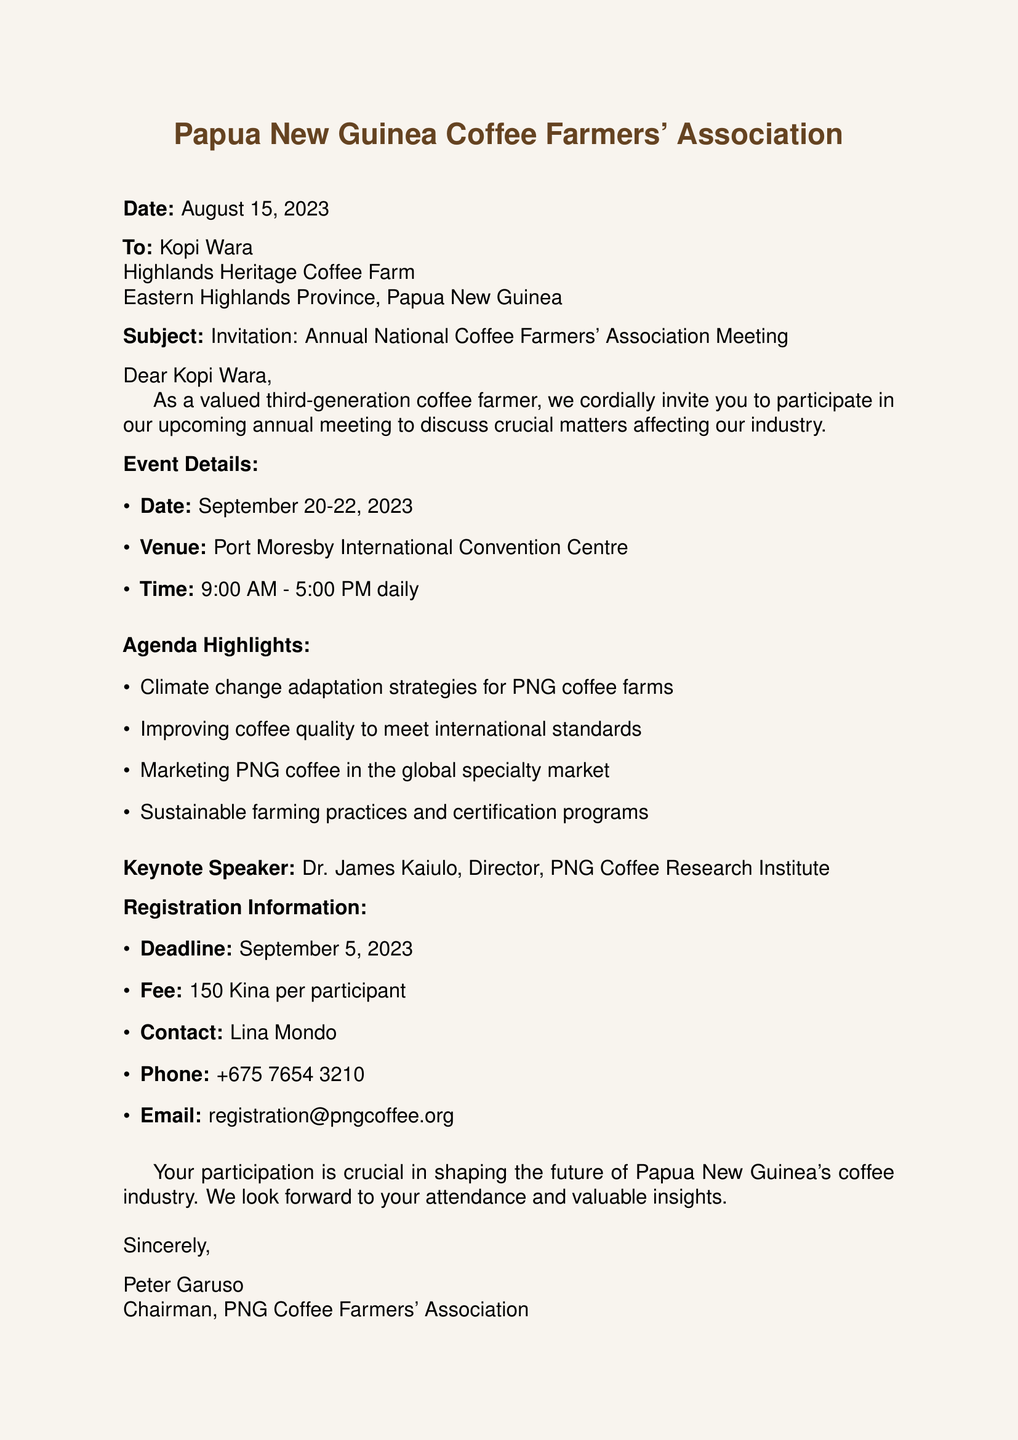What is the date of the meeting? The meeting is scheduled for September 20-22, 2023.
Answer: September 20-22, 2023 What is the venue for the meeting? The venue for the meeting is the Port Moresby International Convention Centre.
Answer: Port Moresby International Convention Centre Who is the keynote speaker? The keynote speaker at the event is Dr. James Kaiulo.
Answer: Dr. James Kaiulo What is the registration deadline? The deadline for registration is September 5, 2023.
Answer: September 5, 2023 What is the registration fee? The fee to register for the event is 150 Kina per participant.
Answer: 150 Kina What are some agenda highlights? Some agenda highlights include climate change adaptation and improving coffee quality.
Answer: Climate change adaptation strategies for PNG coffee farms, Improving coffee quality to meet international standards Why is participation described as crucial? Participation is considered crucial for shaping the future of Papua New Guinea's coffee industry.
Answer: To shape the future of Papua New Guinea's coffee industry Who is the chairman of the association? The chairman of the association is Peter Garuso.
Answer: Peter Garuso 